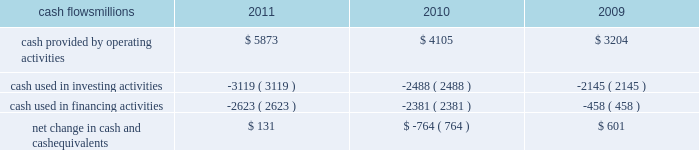Liquidity and capital resources as of december 31 , 2011 , our principal sources of liquidity included cash , cash equivalents , our receivables securitization facility , and our revolving credit facility , as well as the availability of commercial paper and other sources of financing through the capital markets .
We had $ 1.8 billion of committed credit available under our credit facility , with no borrowings outstanding as of december 31 , 2011 .
We did not make any borrowings under this facility during 2011 .
The value of the outstanding undivided interest held by investors under the receivables securitization facility was $ 100 million as of december 31 , 2011 , and is included in our consolidated statements of financial position as debt due after one year .
The receivables securitization facility obligates us to maintain an investment grade bond rating .
If our bond rating were to deteriorate , it could have an adverse impact on our liquidity .
Access to commercial paper as well as other capital market financings is dependent on market conditions .
Deterioration of our operating results or financial condition due to internal or external factors could negatively impact our ability to access capital markets as a source of liquidity .
Access to liquidity through the capital markets is also dependent on our financial stability .
We expect that we will continue to have access to liquidity by issuing bonds to public or private investors based on our assessment of the current condition of the credit markets .
At december 31 , 2011 and 2010 , we had a working capital surplus .
This reflects a strong cash position , which provides enhanced liquidity in an uncertain economic environment .
In addition , we believe we have adequate access to capital markets to meet cash requirements , and we have sufficient financial capacity to satisfy our current liabilities .
Cash flows millions 2011 2010 2009 .
Operating activities higher net income and lower cash income tax payments in 2011 increased cash provided by operating activities compared to 2010 .
The tax relief , unemployment insurance reauthorization , and job creation act of 2010 , enacted in december 2010 , provided for 100% ( 100 % ) bonus depreciation for qualified investments made during 2011 , and 50% ( 50 % ) bonus depreciation for qualified investments made during 2012 .
As a result of the act , the company deferred a substantial portion of its 2011 income tax expense .
This deferral decreased 2011 income tax payments , thereby contributing to the positive operating cash flow .
In future years , however , additional cash will be used to pay income taxes that were previously deferred .
In addition , the adoption of a new accounting standard in january of 2010 changed the accounting treatment for our receivables securitization facility from a sale of undivided interests ( recorded as an operating activity ) to a secured borrowing ( recorded as a financing activity ) , which decreased cash provided by operating activities by $ 400 million in 2010 .
Higher net income in 2010 increased cash provided by operating activities compared to 2009 .
Investing activities higher capital investments partially offset by higher proceeds from asset sales in 2011 drove the increase in cash used in investing activities compared to 2010 .
Higher capital investments and lower proceeds from asset sales in 2010 drove the increase in cash used in investing activities compared to 2009. .
What was the change in cash provided by operating activities from 2009 to 2010 , in millions? 
Computations: (4105 - 3204)
Answer: 901.0. 